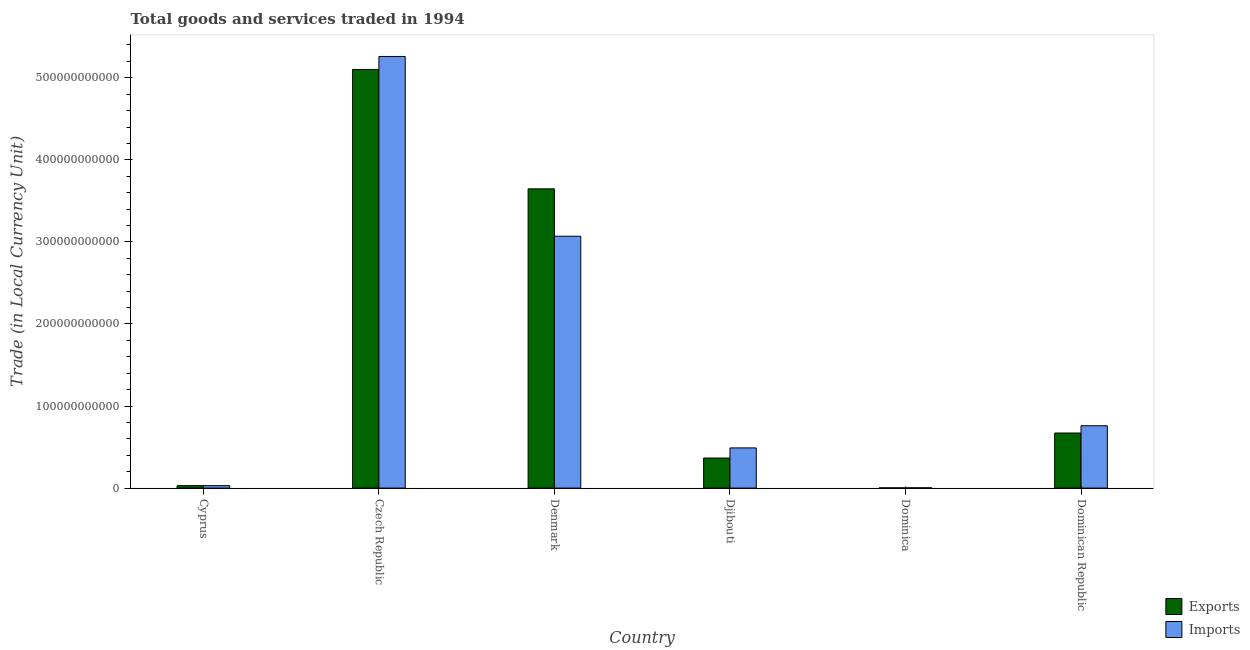How many groups of bars are there?
Keep it short and to the point. 6. Are the number of bars on each tick of the X-axis equal?
Offer a terse response. Yes. How many bars are there on the 4th tick from the right?
Make the answer very short. 2. What is the label of the 1st group of bars from the left?
Offer a terse response. Cyprus. What is the imports of goods and services in Dominica?
Offer a terse response. 3.65e+08. Across all countries, what is the maximum imports of goods and services?
Provide a short and direct response. 5.26e+11. Across all countries, what is the minimum export of goods and services?
Offer a terse response. 2.85e+08. In which country was the export of goods and services maximum?
Your answer should be compact. Czech Republic. In which country was the imports of goods and services minimum?
Give a very brief answer. Dominica. What is the total imports of goods and services in the graph?
Offer a very short reply. 9.61e+11. What is the difference between the imports of goods and services in Djibouti and that in Dominica?
Make the answer very short. 4.86e+1. What is the difference between the export of goods and services in Cyprus and the imports of goods and services in Czech Republic?
Offer a very short reply. -5.23e+11. What is the average export of goods and services per country?
Give a very brief answer. 1.64e+11. What is the difference between the imports of goods and services and export of goods and services in Czech Republic?
Give a very brief answer. 1.58e+1. In how many countries, is the export of goods and services greater than 460000000000 LCU?
Make the answer very short. 1. What is the ratio of the imports of goods and services in Cyprus to that in Dominica?
Give a very brief answer. 8.21. What is the difference between the highest and the second highest imports of goods and services?
Provide a short and direct response. 2.19e+11. What is the difference between the highest and the lowest export of goods and services?
Make the answer very short. 5.10e+11. What does the 2nd bar from the left in Denmark represents?
Provide a succinct answer. Imports. What does the 1st bar from the right in Czech Republic represents?
Keep it short and to the point. Imports. How many bars are there?
Your answer should be compact. 12. Are all the bars in the graph horizontal?
Provide a short and direct response. No. What is the difference between two consecutive major ticks on the Y-axis?
Make the answer very short. 1.00e+11. Does the graph contain any zero values?
Your answer should be very brief. No. Where does the legend appear in the graph?
Your response must be concise. Bottom right. What is the title of the graph?
Keep it short and to the point. Total goods and services traded in 1994. Does "Highest 20% of population" appear as one of the legend labels in the graph?
Make the answer very short. No. What is the label or title of the Y-axis?
Provide a succinct answer. Trade (in Local Currency Unit). What is the Trade (in Local Currency Unit) of Exports in Cyprus?
Your answer should be compact. 2.97e+09. What is the Trade (in Local Currency Unit) of Imports in Cyprus?
Offer a very short reply. 3.00e+09. What is the Trade (in Local Currency Unit) in Exports in Czech Republic?
Your answer should be very brief. 5.10e+11. What is the Trade (in Local Currency Unit) in Imports in Czech Republic?
Make the answer very short. 5.26e+11. What is the Trade (in Local Currency Unit) of Exports in Denmark?
Give a very brief answer. 3.65e+11. What is the Trade (in Local Currency Unit) in Imports in Denmark?
Provide a short and direct response. 3.07e+11. What is the Trade (in Local Currency Unit) of Exports in Djibouti?
Your answer should be very brief. 3.66e+1. What is the Trade (in Local Currency Unit) in Imports in Djibouti?
Keep it short and to the point. 4.90e+1. What is the Trade (in Local Currency Unit) in Exports in Dominica?
Your response must be concise. 2.85e+08. What is the Trade (in Local Currency Unit) of Imports in Dominica?
Your answer should be very brief. 3.65e+08. What is the Trade (in Local Currency Unit) of Exports in Dominican Republic?
Offer a very short reply. 6.71e+1. What is the Trade (in Local Currency Unit) in Imports in Dominican Republic?
Your answer should be very brief. 7.60e+1. Across all countries, what is the maximum Trade (in Local Currency Unit) of Exports?
Offer a terse response. 5.10e+11. Across all countries, what is the maximum Trade (in Local Currency Unit) of Imports?
Provide a succinct answer. 5.26e+11. Across all countries, what is the minimum Trade (in Local Currency Unit) of Exports?
Give a very brief answer. 2.85e+08. Across all countries, what is the minimum Trade (in Local Currency Unit) of Imports?
Provide a short and direct response. 3.65e+08. What is the total Trade (in Local Currency Unit) of Exports in the graph?
Provide a succinct answer. 9.82e+11. What is the total Trade (in Local Currency Unit) of Imports in the graph?
Provide a succinct answer. 9.61e+11. What is the difference between the Trade (in Local Currency Unit) of Exports in Cyprus and that in Czech Republic?
Your answer should be very brief. -5.07e+11. What is the difference between the Trade (in Local Currency Unit) in Imports in Cyprus and that in Czech Republic?
Ensure brevity in your answer.  -5.23e+11. What is the difference between the Trade (in Local Currency Unit) in Exports in Cyprus and that in Denmark?
Your answer should be very brief. -3.62e+11. What is the difference between the Trade (in Local Currency Unit) in Imports in Cyprus and that in Denmark?
Keep it short and to the point. -3.04e+11. What is the difference between the Trade (in Local Currency Unit) in Exports in Cyprus and that in Djibouti?
Your answer should be compact. -3.37e+1. What is the difference between the Trade (in Local Currency Unit) in Imports in Cyprus and that in Djibouti?
Offer a very short reply. -4.60e+1. What is the difference between the Trade (in Local Currency Unit) in Exports in Cyprus and that in Dominica?
Provide a succinct answer. 2.69e+09. What is the difference between the Trade (in Local Currency Unit) in Imports in Cyprus and that in Dominica?
Ensure brevity in your answer.  2.63e+09. What is the difference between the Trade (in Local Currency Unit) in Exports in Cyprus and that in Dominican Republic?
Your answer should be compact. -6.41e+1. What is the difference between the Trade (in Local Currency Unit) in Imports in Cyprus and that in Dominican Republic?
Offer a terse response. -7.30e+1. What is the difference between the Trade (in Local Currency Unit) in Exports in Czech Republic and that in Denmark?
Keep it short and to the point. 1.46e+11. What is the difference between the Trade (in Local Currency Unit) of Imports in Czech Republic and that in Denmark?
Keep it short and to the point. 2.19e+11. What is the difference between the Trade (in Local Currency Unit) of Exports in Czech Republic and that in Djibouti?
Your answer should be compact. 4.74e+11. What is the difference between the Trade (in Local Currency Unit) of Imports in Czech Republic and that in Djibouti?
Your answer should be compact. 4.77e+11. What is the difference between the Trade (in Local Currency Unit) in Exports in Czech Republic and that in Dominica?
Keep it short and to the point. 5.10e+11. What is the difference between the Trade (in Local Currency Unit) of Imports in Czech Republic and that in Dominica?
Ensure brevity in your answer.  5.26e+11. What is the difference between the Trade (in Local Currency Unit) of Exports in Czech Republic and that in Dominican Republic?
Offer a very short reply. 4.43e+11. What is the difference between the Trade (in Local Currency Unit) of Imports in Czech Republic and that in Dominican Republic?
Offer a very short reply. 4.50e+11. What is the difference between the Trade (in Local Currency Unit) in Exports in Denmark and that in Djibouti?
Your response must be concise. 3.28e+11. What is the difference between the Trade (in Local Currency Unit) of Imports in Denmark and that in Djibouti?
Your response must be concise. 2.58e+11. What is the difference between the Trade (in Local Currency Unit) of Exports in Denmark and that in Dominica?
Give a very brief answer. 3.64e+11. What is the difference between the Trade (in Local Currency Unit) in Imports in Denmark and that in Dominica?
Offer a terse response. 3.07e+11. What is the difference between the Trade (in Local Currency Unit) of Exports in Denmark and that in Dominican Republic?
Your answer should be compact. 2.98e+11. What is the difference between the Trade (in Local Currency Unit) in Imports in Denmark and that in Dominican Republic?
Provide a succinct answer. 2.31e+11. What is the difference between the Trade (in Local Currency Unit) in Exports in Djibouti and that in Dominica?
Ensure brevity in your answer.  3.64e+1. What is the difference between the Trade (in Local Currency Unit) of Imports in Djibouti and that in Dominica?
Your answer should be very brief. 4.86e+1. What is the difference between the Trade (in Local Currency Unit) in Exports in Djibouti and that in Dominican Republic?
Keep it short and to the point. -3.05e+1. What is the difference between the Trade (in Local Currency Unit) in Imports in Djibouti and that in Dominican Republic?
Provide a short and direct response. -2.70e+1. What is the difference between the Trade (in Local Currency Unit) of Exports in Dominica and that in Dominican Republic?
Your answer should be compact. -6.68e+1. What is the difference between the Trade (in Local Currency Unit) of Imports in Dominica and that in Dominican Republic?
Ensure brevity in your answer.  -7.56e+1. What is the difference between the Trade (in Local Currency Unit) in Exports in Cyprus and the Trade (in Local Currency Unit) in Imports in Czech Republic?
Keep it short and to the point. -5.23e+11. What is the difference between the Trade (in Local Currency Unit) of Exports in Cyprus and the Trade (in Local Currency Unit) of Imports in Denmark?
Your response must be concise. -3.04e+11. What is the difference between the Trade (in Local Currency Unit) in Exports in Cyprus and the Trade (in Local Currency Unit) in Imports in Djibouti?
Your response must be concise. -4.60e+1. What is the difference between the Trade (in Local Currency Unit) in Exports in Cyprus and the Trade (in Local Currency Unit) in Imports in Dominica?
Give a very brief answer. 2.61e+09. What is the difference between the Trade (in Local Currency Unit) in Exports in Cyprus and the Trade (in Local Currency Unit) in Imports in Dominican Republic?
Give a very brief answer. -7.30e+1. What is the difference between the Trade (in Local Currency Unit) in Exports in Czech Republic and the Trade (in Local Currency Unit) in Imports in Denmark?
Offer a very short reply. 2.03e+11. What is the difference between the Trade (in Local Currency Unit) of Exports in Czech Republic and the Trade (in Local Currency Unit) of Imports in Djibouti?
Your answer should be compact. 4.61e+11. What is the difference between the Trade (in Local Currency Unit) of Exports in Czech Republic and the Trade (in Local Currency Unit) of Imports in Dominica?
Offer a terse response. 5.10e+11. What is the difference between the Trade (in Local Currency Unit) of Exports in Czech Republic and the Trade (in Local Currency Unit) of Imports in Dominican Republic?
Give a very brief answer. 4.34e+11. What is the difference between the Trade (in Local Currency Unit) in Exports in Denmark and the Trade (in Local Currency Unit) in Imports in Djibouti?
Keep it short and to the point. 3.16e+11. What is the difference between the Trade (in Local Currency Unit) of Exports in Denmark and the Trade (in Local Currency Unit) of Imports in Dominica?
Keep it short and to the point. 3.64e+11. What is the difference between the Trade (in Local Currency Unit) of Exports in Denmark and the Trade (in Local Currency Unit) of Imports in Dominican Republic?
Keep it short and to the point. 2.89e+11. What is the difference between the Trade (in Local Currency Unit) in Exports in Djibouti and the Trade (in Local Currency Unit) in Imports in Dominica?
Your answer should be very brief. 3.63e+1. What is the difference between the Trade (in Local Currency Unit) of Exports in Djibouti and the Trade (in Local Currency Unit) of Imports in Dominican Republic?
Your answer should be very brief. -3.93e+1. What is the difference between the Trade (in Local Currency Unit) in Exports in Dominica and the Trade (in Local Currency Unit) in Imports in Dominican Republic?
Keep it short and to the point. -7.57e+1. What is the average Trade (in Local Currency Unit) in Exports per country?
Keep it short and to the point. 1.64e+11. What is the average Trade (in Local Currency Unit) of Imports per country?
Keep it short and to the point. 1.60e+11. What is the difference between the Trade (in Local Currency Unit) in Exports and Trade (in Local Currency Unit) in Imports in Cyprus?
Provide a succinct answer. -2.48e+07. What is the difference between the Trade (in Local Currency Unit) of Exports and Trade (in Local Currency Unit) of Imports in Czech Republic?
Offer a very short reply. -1.58e+1. What is the difference between the Trade (in Local Currency Unit) in Exports and Trade (in Local Currency Unit) in Imports in Denmark?
Provide a succinct answer. 5.77e+1. What is the difference between the Trade (in Local Currency Unit) of Exports and Trade (in Local Currency Unit) of Imports in Djibouti?
Make the answer very short. -1.23e+1. What is the difference between the Trade (in Local Currency Unit) in Exports and Trade (in Local Currency Unit) in Imports in Dominica?
Make the answer very short. -7.99e+07. What is the difference between the Trade (in Local Currency Unit) of Exports and Trade (in Local Currency Unit) of Imports in Dominican Republic?
Ensure brevity in your answer.  -8.87e+09. What is the ratio of the Trade (in Local Currency Unit) of Exports in Cyprus to that in Czech Republic?
Offer a very short reply. 0.01. What is the ratio of the Trade (in Local Currency Unit) in Imports in Cyprus to that in Czech Republic?
Ensure brevity in your answer.  0.01. What is the ratio of the Trade (in Local Currency Unit) of Exports in Cyprus to that in Denmark?
Ensure brevity in your answer.  0.01. What is the ratio of the Trade (in Local Currency Unit) of Imports in Cyprus to that in Denmark?
Your response must be concise. 0.01. What is the ratio of the Trade (in Local Currency Unit) of Exports in Cyprus to that in Djibouti?
Your answer should be very brief. 0.08. What is the ratio of the Trade (in Local Currency Unit) in Imports in Cyprus to that in Djibouti?
Your response must be concise. 0.06. What is the ratio of the Trade (in Local Currency Unit) in Exports in Cyprus to that in Dominica?
Ensure brevity in your answer.  10.42. What is the ratio of the Trade (in Local Currency Unit) in Imports in Cyprus to that in Dominica?
Offer a very short reply. 8.21. What is the ratio of the Trade (in Local Currency Unit) of Exports in Cyprus to that in Dominican Republic?
Provide a short and direct response. 0.04. What is the ratio of the Trade (in Local Currency Unit) in Imports in Cyprus to that in Dominican Republic?
Provide a succinct answer. 0.04. What is the ratio of the Trade (in Local Currency Unit) of Exports in Czech Republic to that in Denmark?
Offer a very short reply. 1.4. What is the ratio of the Trade (in Local Currency Unit) of Imports in Czech Republic to that in Denmark?
Your response must be concise. 1.71. What is the ratio of the Trade (in Local Currency Unit) of Exports in Czech Republic to that in Djibouti?
Make the answer very short. 13.93. What is the ratio of the Trade (in Local Currency Unit) of Imports in Czech Republic to that in Djibouti?
Your response must be concise. 10.74. What is the ratio of the Trade (in Local Currency Unit) of Exports in Czech Republic to that in Dominica?
Give a very brief answer. 1787.73. What is the ratio of the Trade (in Local Currency Unit) of Imports in Czech Republic to that in Dominica?
Give a very brief answer. 1439.94. What is the ratio of the Trade (in Local Currency Unit) of Exports in Czech Republic to that in Dominican Republic?
Your answer should be compact. 7.6. What is the ratio of the Trade (in Local Currency Unit) in Imports in Czech Republic to that in Dominican Republic?
Offer a very short reply. 6.92. What is the ratio of the Trade (in Local Currency Unit) in Exports in Denmark to that in Djibouti?
Your answer should be very brief. 9.95. What is the ratio of the Trade (in Local Currency Unit) in Imports in Denmark to that in Djibouti?
Provide a succinct answer. 6.27. What is the ratio of the Trade (in Local Currency Unit) of Exports in Denmark to that in Dominica?
Keep it short and to the point. 1277.86. What is the ratio of the Trade (in Local Currency Unit) of Imports in Denmark to that in Dominica?
Your answer should be compact. 840.21. What is the ratio of the Trade (in Local Currency Unit) of Exports in Denmark to that in Dominican Republic?
Your answer should be very brief. 5.43. What is the ratio of the Trade (in Local Currency Unit) in Imports in Denmark to that in Dominican Republic?
Offer a very short reply. 4.04. What is the ratio of the Trade (in Local Currency Unit) of Exports in Djibouti to that in Dominica?
Keep it short and to the point. 128.38. What is the ratio of the Trade (in Local Currency Unit) in Imports in Djibouti to that in Dominica?
Offer a very short reply. 134.03. What is the ratio of the Trade (in Local Currency Unit) of Exports in Djibouti to that in Dominican Republic?
Ensure brevity in your answer.  0.55. What is the ratio of the Trade (in Local Currency Unit) in Imports in Djibouti to that in Dominican Republic?
Provide a succinct answer. 0.64. What is the ratio of the Trade (in Local Currency Unit) in Exports in Dominica to that in Dominican Republic?
Provide a succinct answer. 0. What is the ratio of the Trade (in Local Currency Unit) of Imports in Dominica to that in Dominican Republic?
Your response must be concise. 0. What is the difference between the highest and the second highest Trade (in Local Currency Unit) in Exports?
Your answer should be compact. 1.46e+11. What is the difference between the highest and the second highest Trade (in Local Currency Unit) in Imports?
Offer a terse response. 2.19e+11. What is the difference between the highest and the lowest Trade (in Local Currency Unit) in Exports?
Provide a short and direct response. 5.10e+11. What is the difference between the highest and the lowest Trade (in Local Currency Unit) in Imports?
Provide a succinct answer. 5.26e+11. 